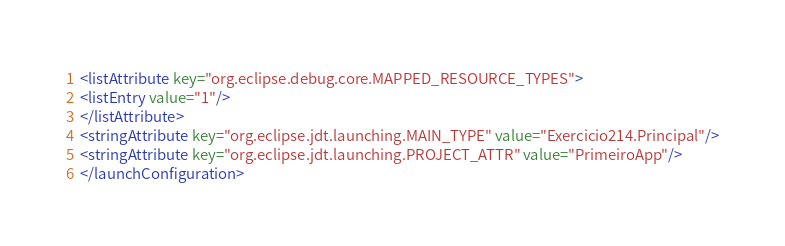<code> <loc_0><loc_0><loc_500><loc_500><_XML_><listAttribute key="org.eclipse.debug.core.MAPPED_RESOURCE_TYPES">
<listEntry value="1"/>
</listAttribute>
<stringAttribute key="org.eclipse.jdt.launching.MAIN_TYPE" value="Exercicio214.Principal"/>
<stringAttribute key="org.eclipse.jdt.launching.PROJECT_ATTR" value="PrimeiroApp"/>
</launchConfiguration>
</code> 